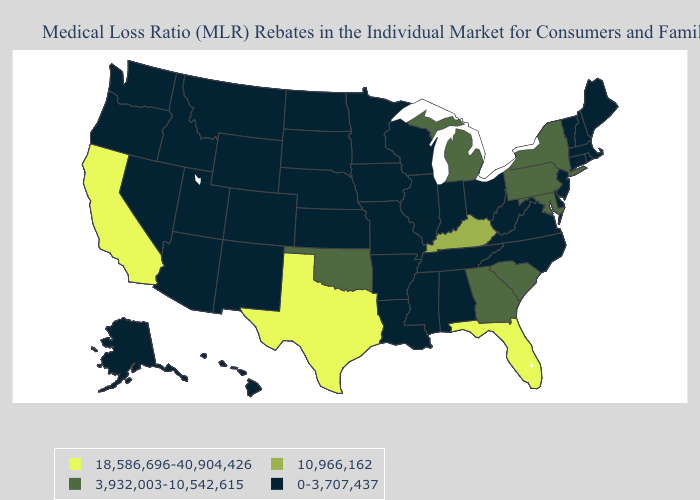What is the value of Minnesota?
Keep it brief. 0-3,707,437. Name the states that have a value in the range 18,586,696-40,904,426?
Keep it brief. California, Florida, Texas. What is the lowest value in the USA?
Write a very short answer. 0-3,707,437. What is the highest value in the USA?
Be succinct. 18,586,696-40,904,426. Among the states that border Mississippi , which have the highest value?
Concise answer only. Alabama, Arkansas, Louisiana, Tennessee. Does Alaska have the lowest value in the USA?
Keep it brief. Yes. Which states have the lowest value in the MidWest?
Short answer required. Illinois, Indiana, Iowa, Kansas, Minnesota, Missouri, Nebraska, North Dakota, Ohio, South Dakota, Wisconsin. Does the first symbol in the legend represent the smallest category?
Keep it brief. No. What is the value of Indiana?
Short answer required. 0-3,707,437. What is the value of Hawaii?
Quick response, please. 0-3,707,437. What is the value of California?
Be succinct. 18,586,696-40,904,426. Name the states that have a value in the range 10,966,162?
Answer briefly. Kentucky. What is the value of Virginia?
Keep it brief. 0-3,707,437. Is the legend a continuous bar?
Give a very brief answer. No. Is the legend a continuous bar?
Short answer required. No. 